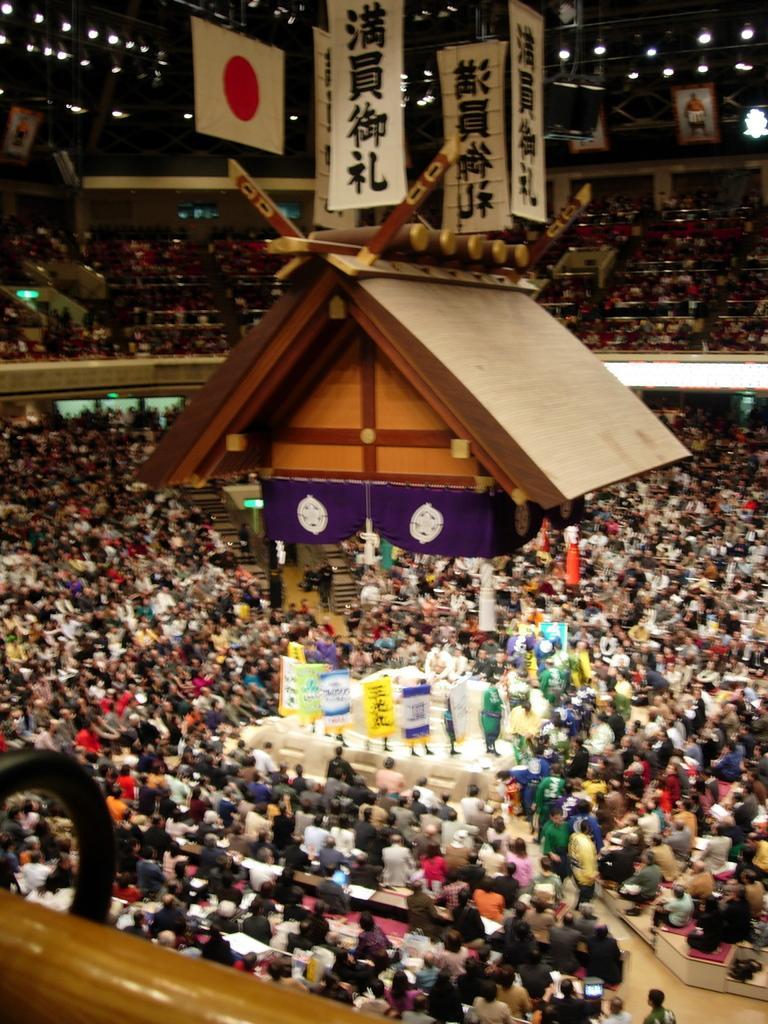In one or two sentences, can you explain what this image depicts? In the image in the center we can see one wooden house,roof,banners,fence,staircase,stage and group of people were sitting. In the background there is a wall, roof,lights,banners,group of people were sitting and few other objects. 